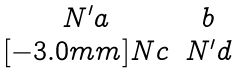Convert formula to latex. <formula><loc_0><loc_0><loc_500><loc_500>\begin{matrix} N ^ { \prime } a & b \\ [ - 3 . 0 m m ] N c & N ^ { \prime } d \end{matrix}</formula> 